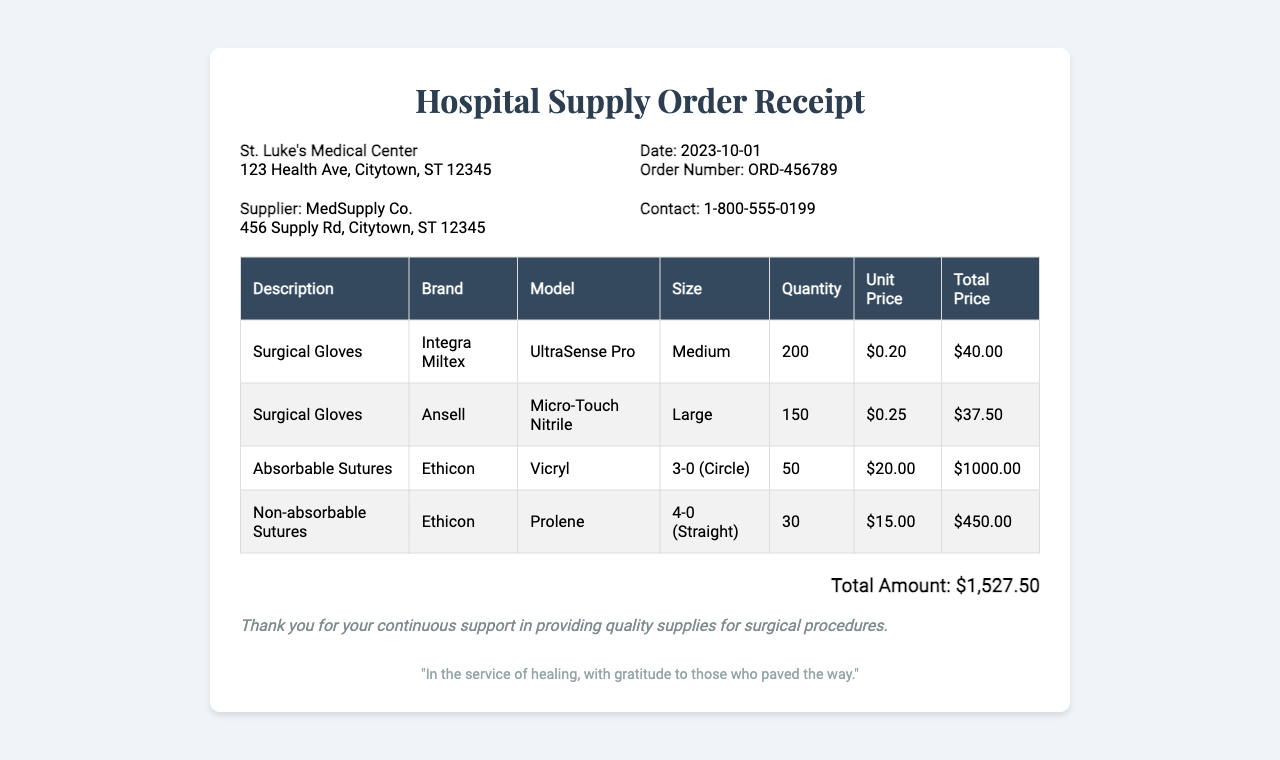What is the order number? The order number is specified in the document, which is ORD-456789.
Answer: ORD-456789 Who is the supplier? The supplier name is listed in the document as MedSupply Co.
Answer: MedSupply Co What is the total amount? The total amount, calculated from all items in the document, is shown at the bottom as $1,527.50.
Answer: $1,527.50 How many surgical gloves of the brand Integra Miltex were ordered? The quantity for Integra Miltex surgical gloves is detailed in the table as 200.
Answer: 200 What is the size of the absorbable sutures? The size of the absorbable sutures is mentioned in the document as 3-0 (Circle).
Answer: 3-0 (Circle) Which brand provides the non-absorbable sutures? The brand for non-absorbable sutures is noted in the table as Ethicon.
Answer: Ethicon How much did the non-absorbable sutures cost? The cost for non-absorbable sutures is clearly indicated as $450.00.
Answer: $450.00 What date was the order placed? The date of the order is provided in the document as 2023-10-01.
Answer: 2023-10-01 What type of suture is listed as "Vicryl"? "Vicryl" is categorized as an absorbable suture in the document.
Answer: Absorbable sutures 